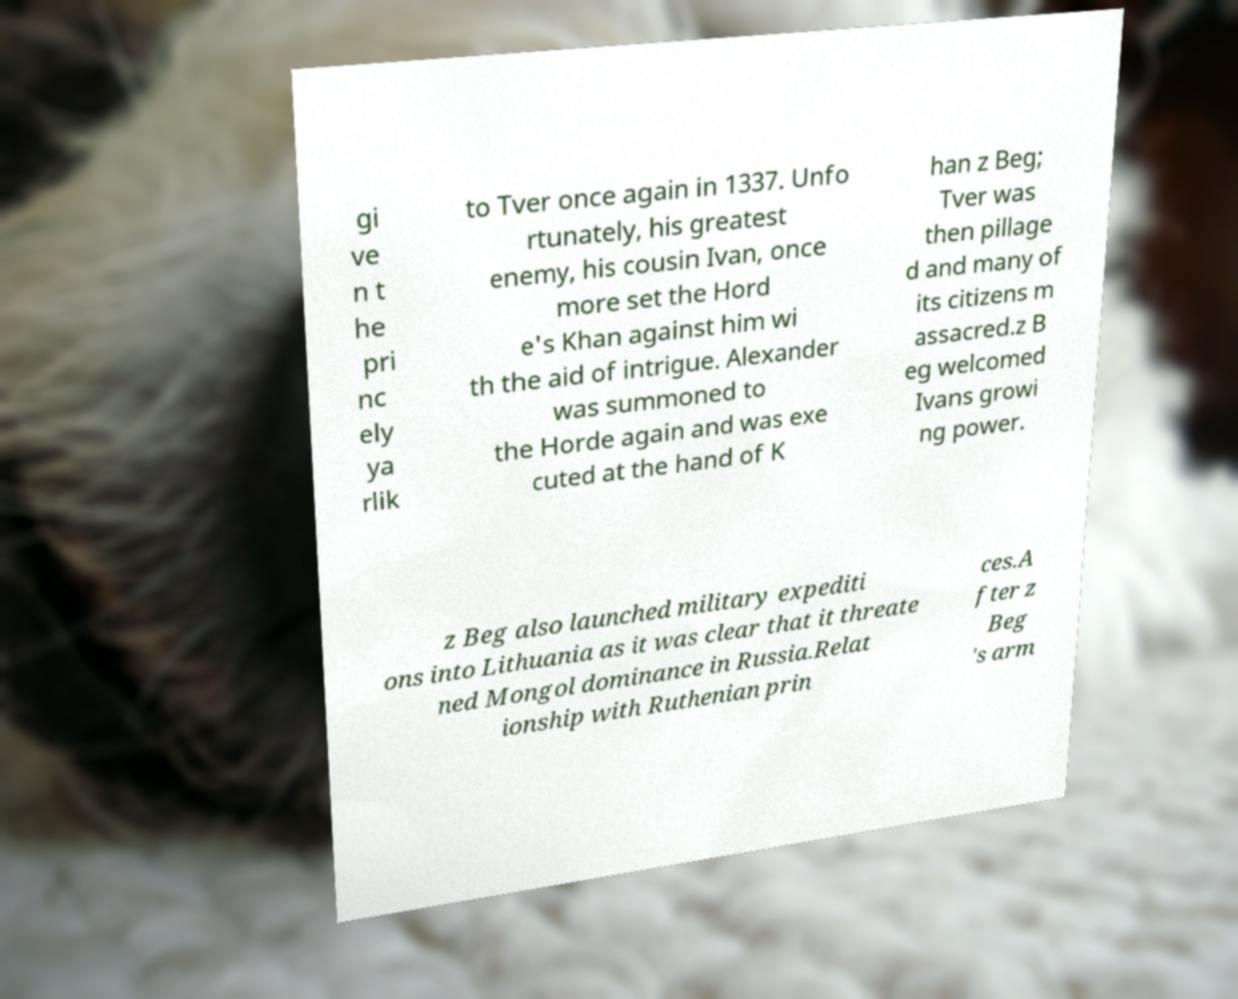There's text embedded in this image that I need extracted. Can you transcribe it verbatim? gi ve n t he pri nc ely ya rlik to Tver once again in 1337. Unfo rtunately, his greatest enemy, his cousin Ivan, once more set the Hord e's Khan against him wi th the aid of intrigue. Alexander was summoned to the Horde again and was exe cuted at the hand of K han z Beg; Tver was then pillage d and many of its citizens m assacred.z B eg welcomed Ivans growi ng power. z Beg also launched military expediti ons into Lithuania as it was clear that it threate ned Mongol dominance in Russia.Relat ionship with Ruthenian prin ces.A fter z Beg 's arm 